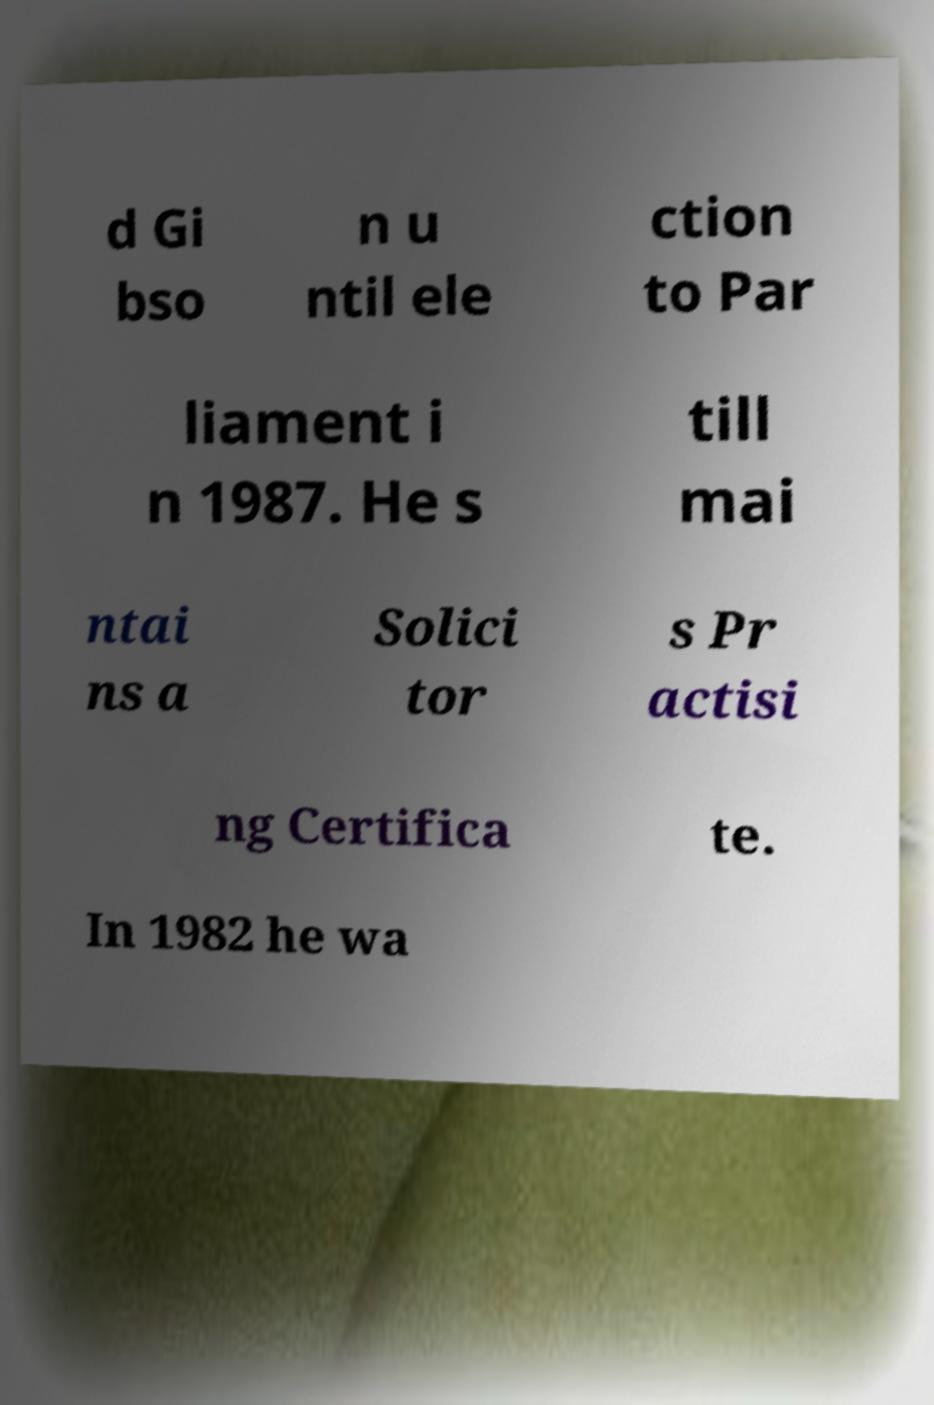Could you assist in decoding the text presented in this image and type it out clearly? d Gi bso n u ntil ele ction to Par liament i n 1987. He s till mai ntai ns a Solici tor s Pr actisi ng Certifica te. In 1982 he wa 